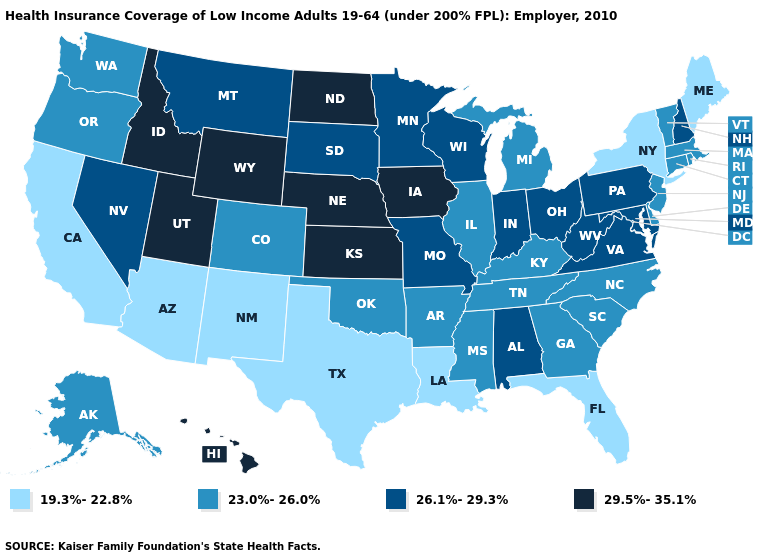Does the first symbol in the legend represent the smallest category?
Answer briefly. Yes. Name the states that have a value in the range 19.3%-22.8%?
Give a very brief answer. Arizona, California, Florida, Louisiana, Maine, New Mexico, New York, Texas. Does New Mexico have the highest value in the USA?
Keep it brief. No. Name the states that have a value in the range 23.0%-26.0%?
Be succinct. Alaska, Arkansas, Colorado, Connecticut, Delaware, Georgia, Illinois, Kentucky, Massachusetts, Michigan, Mississippi, New Jersey, North Carolina, Oklahoma, Oregon, Rhode Island, South Carolina, Tennessee, Vermont, Washington. Does New Hampshire have the same value as Alaska?
Answer briefly. No. Does Wisconsin have the highest value in the USA?
Concise answer only. No. Name the states that have a value in the range 26.1%-29.3%?
Give a very brief answer. Alabama, Indiana, Maryland, Minnesota, Missouri, Montana, Nevada, New Hampshire, Ohio, Pennsylvania, South Dakota, Virginia, West Virginia, Wisconsin. Name the states that have a value in the range 29.5%-35.1%?
Answer briefly. Hawaii, Idaho, Iowa, Kansas, Nebraska, North Dakota, Utah, Wyoming. Name the states that have a value in the range 19.3%-22.8%?
Answer briefly. Arizona, California, Florida, Louisiana, Maine, New Mexico, New York, Texas. What is the highest value in the USA?
Give a very brief answer. 29.5%-35.1%. Name the states that have a value in the range 23.0%-26.0%?
Give a very brief answer. Alaska, Arkansas, Colorado, Connecticut, Delaware, Georgia, Illinois, Kentucky, Massachusetts, Michigan, Mississippi, New Jersey, North Carolina, Oklahoma, Oregon, Rhode Island, South Carolina, Tennessee, Vermont, Washington. What is the value of Rhode Island?
Keep it brief. 23.0%-26.0%. What is the lowest value in the USA?
Be succinct. 19.3%-22.8%. Does Texas have the lowest value in the USA?
Keep it brief. Yes. 